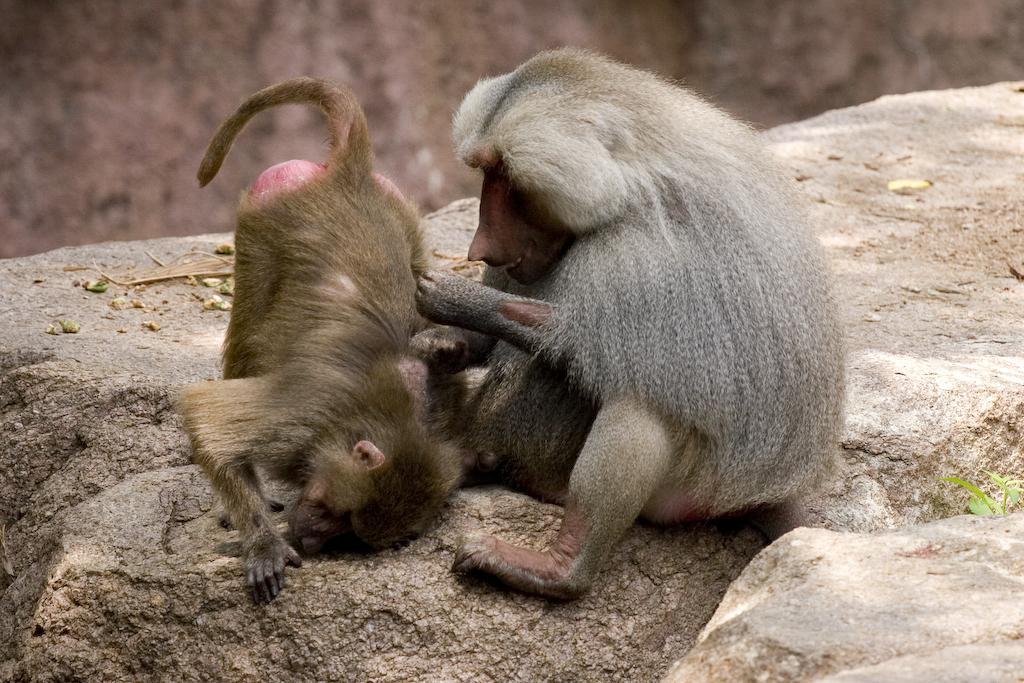Describe this image in one or two sentences. In this picture I can see two monkeys on the rocks, and there is blur background. 